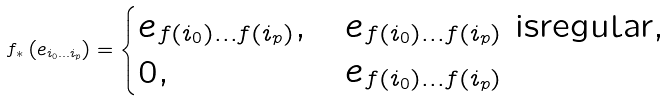<formula> <loc_0><loc_0><loc_500><loc_500>f _ { \ast } \left ( e _ { i _ { 0 } \dots i _ { p } } \right ) = \begin{cases} e _ { f ( i _ { 0 } ) \dots f ( i _ { p } ) } , & e _ { f ( i _ { 0 } ) \dots f ( i _ { p } ) } \text { isregular,} \\ 0 , & e _ { f ( i _ { 0 } ) \dots f ( i _ { p } ) } \ \end{cases}</formula> 